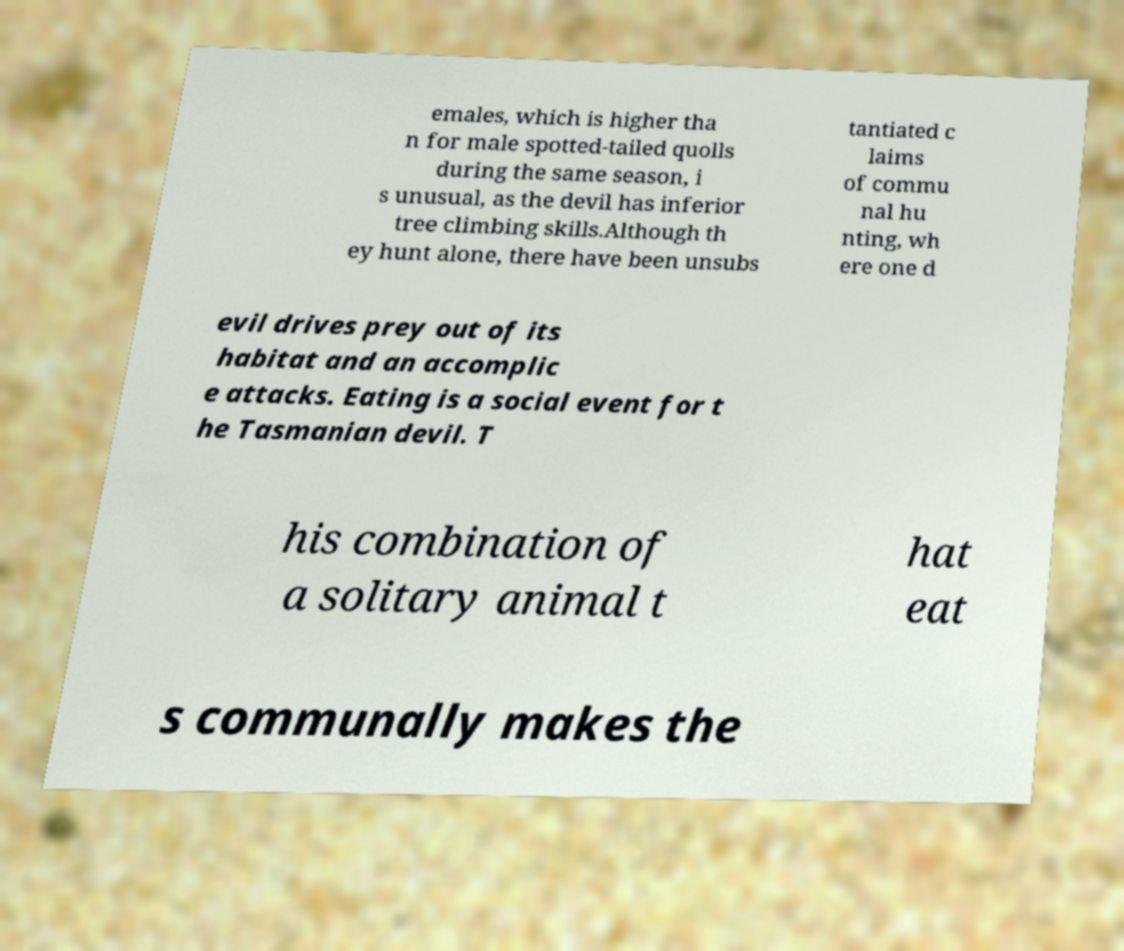Could you assist in decoding the text presented in this image and type it out clearly? emales, which is higher tha n for male spotted-tailed quolls during the same season, i s unusual, as the devil has inferior tree climbing skills.Although th ey hunt alone, there have been unsubs tantiated c laims of commu nal hu nting, wh ere one d evil drives prey out of its habitat and an accomplic e attacks. Eating is a social event for t he Tasmanian devil. T his combination of a solitary animal t hat eat s communally makes the 